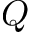Convert formula to latex. <formula><loc_0><loc_0><loc_500><loc_500>Q</formula> 